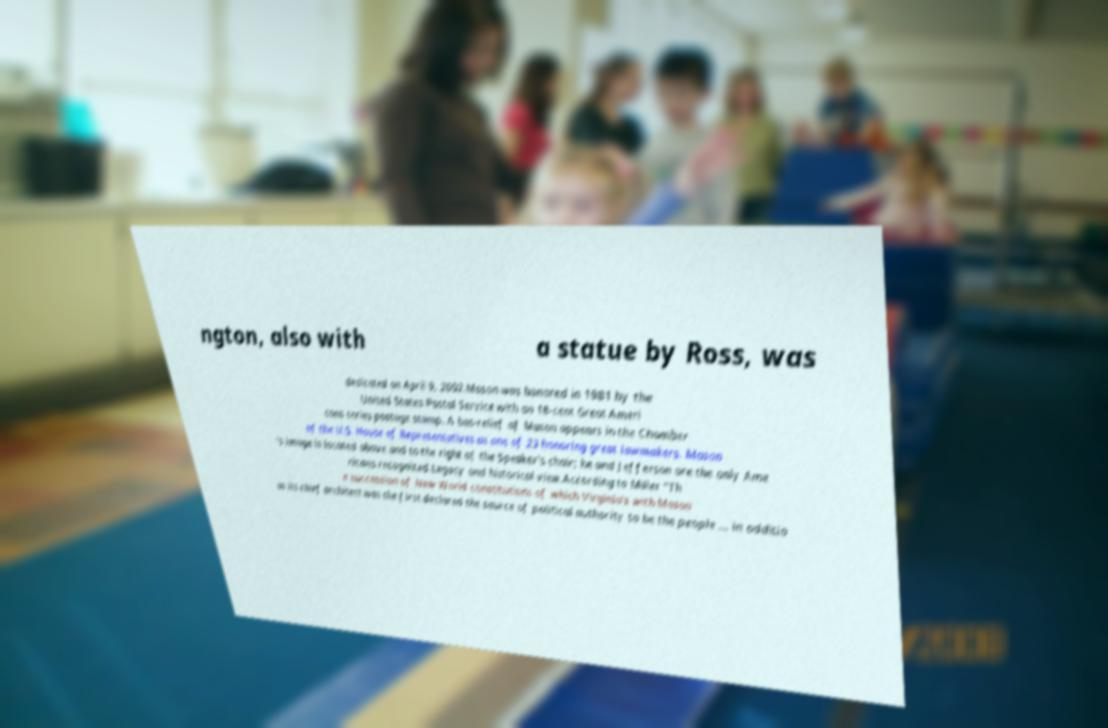There's text embedded in this image that I need extracted. Can you transcribe it verbatim? ngton, also with a statue by Ross, was dedicated on April 9, 2002.Mason was honored in 1981 by the United States Postal Service with an 18-cent Great Ameri cans series postage stamp. A bas-relief of Mason appears in the Chamber of the U.S. House of Representatives as one of 23 honoring great lawmakers. Mason 's image is located above and to the right of the Speaker's chair; he and Jefferson are the only Ame ricans recognized.Legacy and historical view.According to Miller "Th e succession of New World constitutions of which Virginia's with Mason as its chief architect was the first declared the source of political authority to be the people ... in additio 